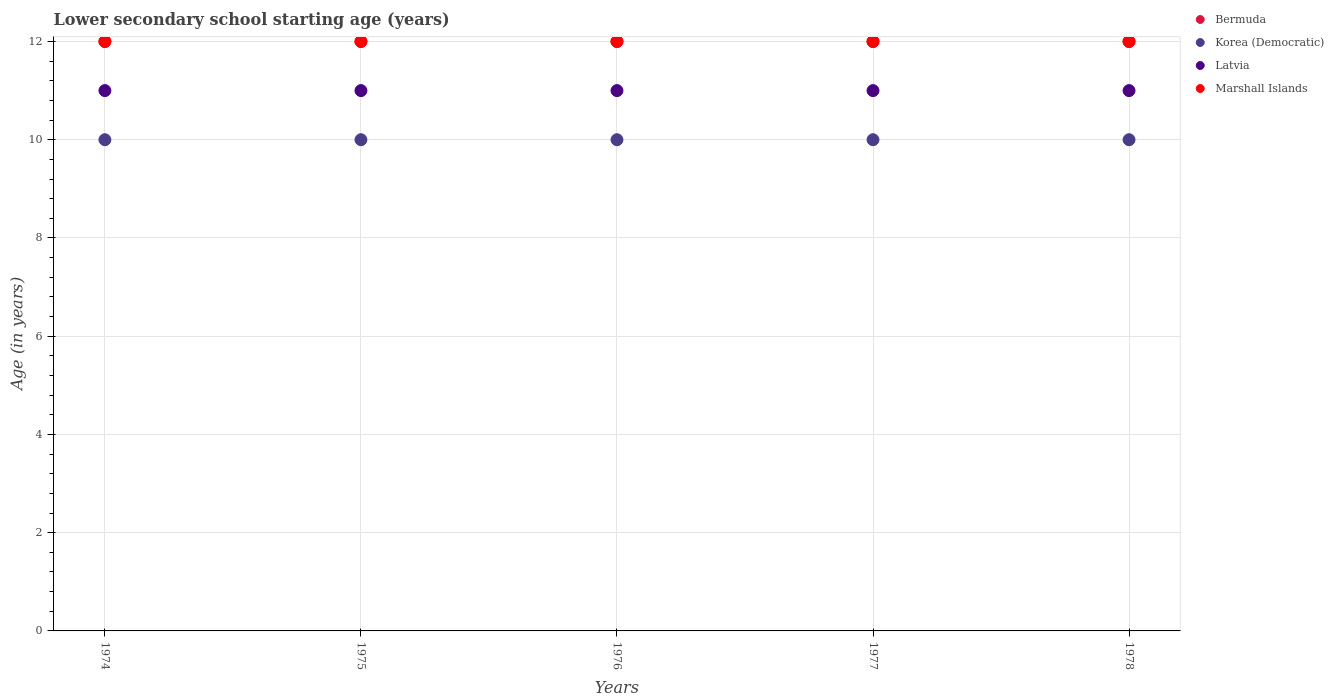Is the number of dotlines equal to the number of legend labels?
Your answer should be very brief. Yes. What is the lower secondary school starting age of children in Marshall Islands in 1974?
Provide a succinct answer. 12. Across all years, what is the maximum lower secondary school starting age of children in Marshall Islands?
Keep it short and to the point. 12. In which year was the lower secondary school starting age of children in Bermuda maximum?
Your response must be concise. 1974. In which year was the lower secondary school starting age of children in Marshall Islands minimum?
Make the answer very short. 1974. What is the total lower secondary school starting age of children in Korea (Democratic) in the graph?
Ensure brevity in your answer.  50. What is the difference between the lower secondary school starting age of children in Bermuda in 1978 and the lower secondary school starting age of children in Marshall Islands in 1974?
Your response must be concise. 0. What is the average lower secondary school starting age of children in Korea (Democratic) per year?
Offer a very short reply. 10. In the year 1974, what is the difference between the lower secondary school starting age of children in Marshall Islands and lower secondary school starting age of children in Korea (Democratic)?
Give a very brief answer. 2. In how many years, is the lower secondary school starting age of children in Latvia greater than 2.8 years?
Make the answer very short. 5. Is the difference between the lower secondary school starting age of children in Marshall Islands in 1974 and 1975 greater than the difference between the lower secondary school starting age of children in Korea (Democratic) in 1974 and 1975?
Give a very brief answer. No. In how many years, is the lower secondary school starting age of children in Bermuda greater than the average lower secondary school starting age of children in Bermuda taken over all years?
Keep it short and to the point. 0. Does the lower secondary school starting age of children in Bermuda monotonically increase over the years?
Your response must be concise. No. Is the lower secondary school starting age of children in Bermuda strictly greater than the lower secondary school starting age of children in Korea (Democratic) over the years?
Provide a succinct answer. Yes. How many years are there in the graph?
Your answer should be very brief. 5. Are the values on the major ticks of Y-axis written in scientific E-notation?
Ensure brevity in your answer.  No. Where does the legend appear in the graph?
Give a very brief answer. Top right. What is the title of the graph?
Provide a short and direct response. Lower secondary school starting age (years). Does "Monaco" appear as one of the legend labels in the graph?
Give a very brief answer. No. What is the label or title of the X-axis?
Make the answer very short. Years. What is the label or title of the Y-axis?
Provide a succinct answer. Age (in years). What is the Age (in years) of Bermuda in 1974?
Ensure brevity in your answer.  12. What is the Age (in years) of Korea (Democratic) in 1974?
Keep it short and to the point. 10. What is the Age (in years) of Latvia in 1975?
Give a very brief answer. 11. What is the Age (in years) of Bermuda in 1976?
Offer a terse response. 12. What is the Age (in years) of Korea (Democratic) in 1976?
Make the answer very short. 10. What is the Age (in years) in Marshall Islands in 1976?
Offer a very short reply. 12. What is the Age (in years) in Bermuda in 1977?
Ensure brevity in your answer.  12. What is the Age (in years) in Latvia in 1977?
Your answer should be very brief. 11. What is the Age (in years) of Marshall Islands in 1977?
Your answer should be very brief. 12. What is the Age (in years) in Bermuda in 1978?
Provide a short and direct response. 12. What is the Age (in years) of Latvia in 1978?
Your response must be concise. 11. What is the Age (in years) in Marshall Islands in 1978?
Your answer should be compact. 12. Across all years, what is the maximum Age (in years) in Korea (Democratic)?
Make the answer very short. 10. Across all years, what is the minimum Age (in years) of Bermuda?
Provide a succinct answer. 12. Across all years, what is the minimum Age (in years) of Marshall Islands?
Offer a terse response. 12. What is the total Age (in years) in Bermuda in the graph?
Your answer should be very brief. 60. What is the total Age (in years) in Korea (Democratic) in the graph?
Your answer should be compact. 50. What is the total Age (in years) of Latvia in the graph?
Offer a very short reply. 55. What is the difference between the Age (in years) in Latvia in 1974 and that in 1975?
Your response must be concise. 0. What is the difference between the Age (in years) in Marshall Islands in 1974 and that in 1975?
Provide a succinct answer. 0. What is the difference between the Age (in years) of Bermuda in 1974 and that in 1976?
Keep it short and to the point. 0. What is the difference between the Age (in years) of Korea (Democratic) in 1974 and that in 1976?
Your response must be concise. 0. What is the difference between the Age (in years) of Latvia in 1974 and that in 1976?
Give a very brief answer. 0. What is the difference between the Age (in years) of Marshall Islands in 1974 and that in 1976?
Make the answer very short. 0. What is the difference between the Age (in years) in Bermuda in 1974 and that in 1977?
Offer a terse response. 0. What is the difference between the Age (in years) in Marshall Islands in 1974 and that in 1977?
Provide a short and direct response. 0. What is the difference between the Age (in years) of Bermuda in 1974 and that in 1978?
Ensure brevity in your answer.  0. What is the difference between the Age (in years) of Korea (Democratic) in 1974 and that in 1978?
Offer a terse response. 0. What is the difference between the Age (in years) of Bermuda in 1975 and that in 1976?
Ensure brevity in your answer.  0. What is the difference between the Age (in years) in Korea (Democratic) in 1975 and that in 1976?
Your response must be concise. 0. What is the difference between the Age (in years) of Latvia in 1975 and that in 1976?
Ensure brevity in your answer.  0. What is the difference between the Age (in years) in Marshall Islands in 1975 and that in 1976?
Keep it short and to the point. 0. What is the difference between the Age (in years) in Bermuda in 1975 and that in 1977?
Keep it short and to the point. 0. What is the difference between the Age (in years) of Marshall Islands in 1975 and that in 1977?
Your answer should be very brief. 0. What is the difference between the Age (in years) of Bermuda in 1975 and that in 1978?
Your answer should be very brief. 0. What is the difference between the Age (in years) in Latvia in 1975 and that in 1978?
Your answer should be very brief. 0. What is the difference between the Age (in years) of Marshall Islands in 1975 and that in 1978?
Your answer should be very brief. 0. What is the difference between the Age (in years) in Bermuda in 1976 and that in 1977?
Make the answer very short. 0. What is the difference between the Age (in years) in Latvia in 1976 and that in 1977?
Keep it short and to the point. 0. What is the difference between the Age (in years) in Korea (Democratic) in 1976 and that in 1978?
Your response must be concise. 0. What is the difference between the Age (in years) of Marshall Islands in 1976 and that in 1978?
Keep it short and to the point. 0. What is the difference between the Age (in years) in Marshall Islands in 1977 and that in 1978?
Provide a short and direct response. 0. What is the difference between the Age (in years) of Bermuda in 1974 and the Age (in years) of Korea (Democratic) in 1975?
Keep it short and to the point. 2. What is the difference between the Age (in years) in Korea (Democratic) in 1974 and the Age (in years) in Marshall Islands in 1975?
Offer a terse response. -2. What is the difference between the Age (in years) in Latvia in 1974 and the Age (in years) in Marshall Islands in 1975?
Your response must be concise. -1. What is the difference between the Age (in years) in Bermuda in 1974 and the Age (in years) in Korea (Democratic) in 1976?
Your response must be concise. 2. What is the difference between the Age (in years) in Bermuda in 1974 and the Age (in years) in Latvia in 1976?
Give a very brief answer. 1. What is the difference between the Age (in years) in Korea (Democratic) in 1974 and the Age (in years) in Latvia in 1976?
Make the answer very short. -1. What is the difference between the Age (in years) of Latvia in 1974 and the Age (in years) of Marshall Islands in 1976?
Offer a very short reply. -1. What is the difference between the Age (in years) of Bermuda in 1974 and the Age (in years) of Korea (Democratic) in 1977?
Your response must be concise. 2. What is the difference between the Age (in years) in Latvia in 1974 and the Age (in years) in Marshall Islands in 1977?
Offer a terse response. -1. What is the difference between the Age (in years) in Bermuda in 1974 and the Age (in years) in Latvia in 1978?
Keep it short and to the point. 1. What is the difference between the Age (in years) of Bermuda in 1975 and the Age (in years) of Korea (Democratic) in 1976?
Ensure brevity in your answer.  2. What is the difference between the Age (in years) in Bermuda in 1975 and the Age (in years) in Latvia in 1976?
Your response must be concise. 1. What is the difference between the Age (in years) of Korea (Democratic) in 1975 and the Age (in years) of Latvia in 1976?
Offer a very short reply. -1. What is the difference between the Age (in years) of Bermuda in 1975 and the Age (in years) of Korea (Democratic) in 1977?
Make the answer very short. 2. What is the difference between the Age (in years) of Bermuda in 1975 and the Age (in years) of Latvia in 1977?
Ensure brevity in your answer.  1. What is the difference between the Age (in years) in Bermuda in 1975 and the Age (in years) in Marshall Islands in 1977?
Offer a very short reply. 0. What is the difference between the Age (in years) of Korea (Democratic) in 1975 and the Age (in years) of Latvia in 1977?
Offer a very short reply. -1. What is the difference between the Age (in years) of Korea (Democratic) in 1975 and the Age (in years) of Marshall Islands in 1977?
Provide a short and direct response. -2. What is the difference between the Age (in years) of Latvia in 1975 and the Age (in years) of Marshall Islands in 1977?
Make the answer very short. -1. What is the difference between the Age (in years) in Bermuda in 1975 and the Age (in years) in Marshall Islands in 1978?
Give a very brief answer. 0. What is the difference between the Age (in years) of Korea (Democratic) in 1975 and the Age (in years) of Latvia in 1978?
Make the answer very short. -1. What is the difference between the Age (in years) of Latvia in 1975 and the Age (in years) of Marshall Islands in 1978?
Offer a terse response. -1. What is the difference between the Age (in years) in Bermuda in 1976 and the Age (in years) in Korea (Democratic) in 1977?
Give a very brief answer. 2. What is the difference between the Age (in years) of Korea (Democratic) in 1976 and the Age (in years) of Marshall Islands in 1977?
Give a very brief answer. -2. What is the difference between the Age (in years) in Bermuda in 1976 and the Age (in years) in Korea (Democratic) in 1978?
Your answer should be very brief. 2. What is the difference between the Age (in years) of Bermuda in 1976 and the Age (in years) of Latvia in 1978?
Provide a succinct answer. 1. What is the difference between the Age (in years) of Korea (Democratic) in 1976 and the Age (in years) of Latvia in 1978?
Your response must be concise. -1. What is the difference between the Age (in years) of Bermuda in 1977 and the Age (in years) of Korea (Democratic) in 1978?
Your answer should be compact. 2. What is the difference between the Age (in years) in Korea (Democratic) in 1977 and the Age (in years) in Latvia in 1978?
Make the answer very short. -1. What is the difference between the Age (in years) in Latvia in 1977 and the Age (in years) in Marshall Islands in 1978?
Keep it short and to the point. -1. What is the average Age (in years) in Latvia per year?
Provide a succinct answer. 11. What is the average Age (in years) in Marshall Islands per year?
Keep it short and to the point. 12. In the year 1975, what is the difference between the Age (in years) of Bermuda and Age (in years) of Korea (Democratic)?
Provide a succinct answer. 2. In the year 1975, what is the difference between the Age (in years) in Korea (Democratic) and Age (in years) in Marshall Islands?
Keep it short and to the point. -2. In the year 1976, what is the difference between the Age (in years) of Bermuda and Age (in years) of Marshall Islands?
Provide a short and direct response. 0. In the year 1976, what is the difference between the Age (in years) of Korea (Democratic) and Age (in years) of Latvia?
Provide a short and direct response. -1. In the year 1976, what is the difference between the Age (in years) in Korea (Democratic) and Age (in years) in Marshall Islands?
Keep it short and to the point. -2. In the year 1976, what is the difference between the Age (in years) of Latvia and Age (in years) of Marshall Islands?
Provide a short and direct response. -1. In the year 1977, what is the difference between the Age (in years) in Bermuda and Age (in years) in Korea (Democratic)?
Provide a succinct answer. 2. In the year 1977, what is the difference between the Age (in years) of Bermuda and Age (in years) of Latvia?
Your answer should be very brief. 1. In the year 1977, what is the difference between the Age (in years) in Bermuda and Age (in years) in Marshall Islands?
Offer a very short reply. 0. In the year 1977, what is the difference between the Age (in years) of Korea (Democratic) and Age (in years) of Latvia?
Make the answer very short. -1. In the year 1977, what is the difference between the Age (in years) in Latvia and Age (in years) in Marshall Islands?
Your response must be concise. -1. In the year 1978, what is the difference between the Age (in years) in Bermuda and Age (in years) in Latvia?
Your response must be concise. 1. In the year 1978, what is the difference between the Age (in years) in Bermuda and Age (in years) in Marshall Islands?
Keep it short and to the point. 0. In the year 1978, what is the difference between the Age (in years) of Korea (Democratic) and Age (in years) of Marshall Islands?
Provide a succinct answer. -2. In the year 1978, what is the difference between the Age (in years) of Latvia and Age (in years) of Marshall Islands?
Provide a succinct answer. -1. What is the ratio of the Age (in years) of Korea (Democratic) in 1974 to that in 1975?
Your answer should be very brief. 1. What is the ratio of the Age (in years) of Marshall Islands in 1974 to that in 1975?
Give a very brief answer. 1. What is the ratio of the Age (in years) in Bermuda in 1974 to that in 1976?
Offer a very short reply. 1. What is the ratio of the Age (in years) in Korea (Democratic) in 1974 to that in 1976?
Your answer should be very brief. 1. What is the ratio of the Age (in years) in Korea (Democratic) in 1974 to that in 1977?
Your answer should be compact. 1. What is the ratio of the Age (in years) in Marshall Islands in 1974 to that in 1977?
Your answer should be compact. 1. What is the ratio of the Age (in years) of Latvia in 1974 to that in 1978?
Your answer should be compact. 1. What is the ratio of the Age (in years) of Korea (Democratic) in 1975 to that in 1976?
Provide a short and direct response. 1. What is the ratio of the Age (in years) of Marshall Islands in 1975 to that in 1976?
Your response must be concise. 1. What is the ratio of the Age (in years) in Bermuda in 1975 to that in 1977?
Offer a very short reply. 1. What is the ratio of the Age (in years) in Korea (Democratic) in 1975 to that in 1977?
Your answer should be compact. 1. What is the ratio of the Age (in years) of Latvia in 1975 to that in 1977?
Keep it short and to the point. 1. What is the ratio of the Age (in years) of Marshall Islands in 1975 to that in 1977?
Provide a short and direct response. 1. What is the ratio of the Age (in years) of Marshall Islands in 1975 to that in 1978?
Offer a terse response. 1. What is the ratio of the Age (in years) in Korea (Democratic) in 1976 to that in 1977?
Keep it short and to the point. 1. What is the ratio of the Age (in years) of Bermuda in 1976 to that in 1978?
Offer a terse response. 1. What is the ratio of the Age (in years) in Korea (Democratic) in 1976 to that in 1978?
Your answer should be very brief. 1. What is the ratio of the Age (in years) of Latvia in 1976 to that in 1978?
Give a very brief answer. 1. What is the ratio of the Age (in years) in Marshall Islands in 1976 to that in 1978?
Keep it short and to the point. 1. What is the ratio of the Age (in years) in Korea (Democratic) in 1977 to that in 1978?
Your answer should be very brief. 1. What is the ratio of the Age (in years) of Marshall Islands in 1977 to that in 1978?
Keep it short and to the point. 1. What is the difference between the highest and the second highest Age (in years) in Bermuda?
Offer a terse response. 0. What is the difference between the highest and the second highest Age (in years) in Korea (Democratic)?
Give a very brief answer. 0. What is the difference between the highest and the second highest Age (in years) of Latvia?
Ensure brevity in your answer.  0. What is the difference between the highest and the lowest Age (in years) in Bermuda?
Your response must be concise. 0. What is the difference between the highest and the lowest Age (in years) of Marshall Islands?
Ensure brevity in your answer.  0. 